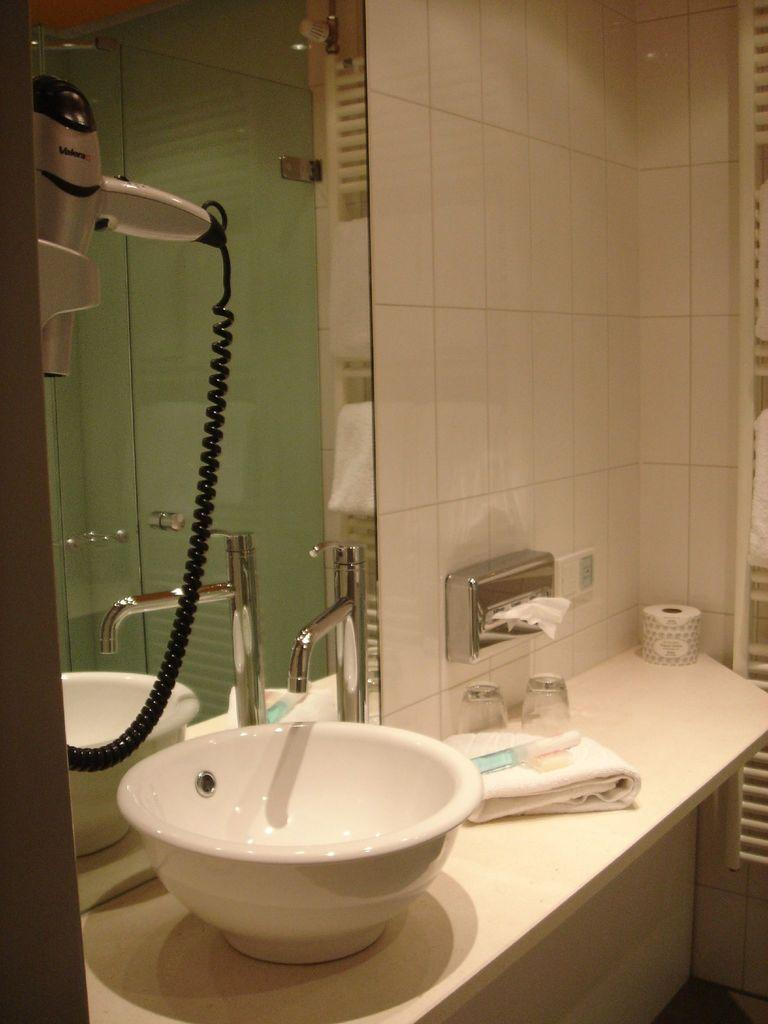What type of room is depicted in the image? The image is of a washroom. What is one fixture commonly found in washrooms that is visible in the image? There is a sink in the image. What is used to control the flow of water in the sink? There is a tap in the image. What item is typically used for drying hands after washing them, and is present in the image? There is a towel in the image. What type of paper is present in the image? There is paper in the image. What is the main structural component of the room visible in the image? There is a wall in the image. What appliance is used for drying clothes and is present in the image? There is a dryer machine in the image. What piece of furniture is present in the image? There is a table in the image. What surface is walked on in the room depicted in the image? There is a floor in the image. Can you see a snail crawling on the wall in the image? No, there is no snail present in the image. What type of instrument is being played in the image? There is no instrument present in the image; it is a washroom setting. 